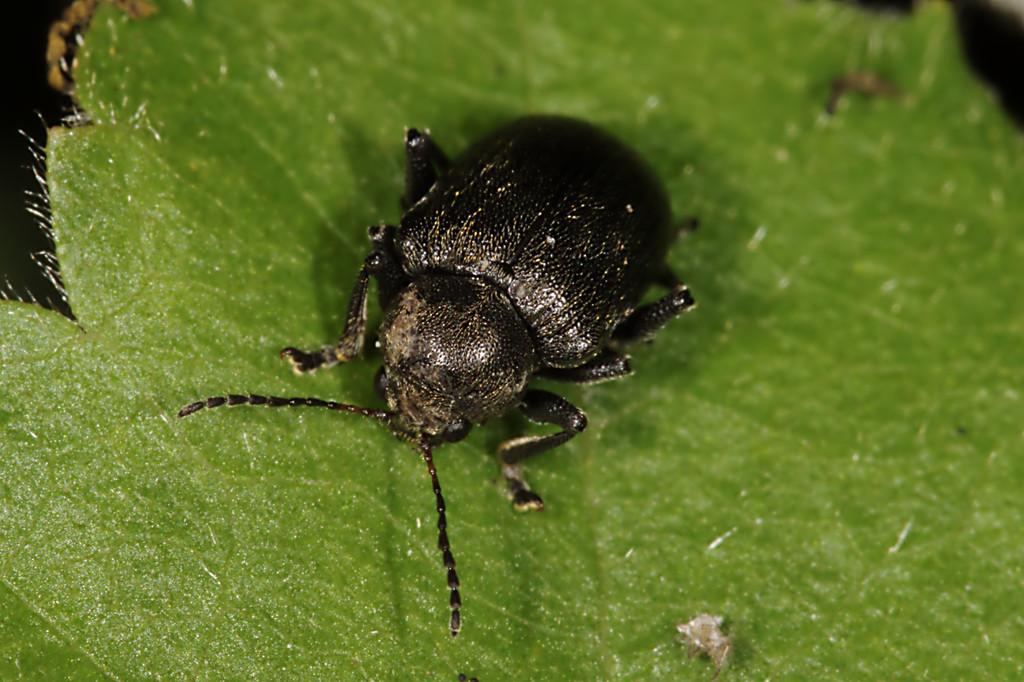What type of creature is present in the image? There is an insect in the image. Where is the insect located? The insect is on a leaf. What type of border is visible around the leaf in the image? There is no border visible around the leaf in the image. What type of plant does the leaf belong to in the image? The provided facts do not specify the type of plant the leaf belongs to. 